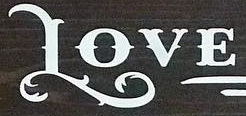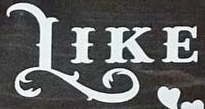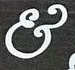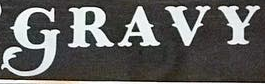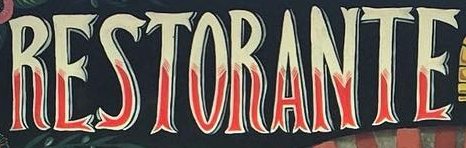Read the text content from these images in order, separated by a semicolon. LOVE; LIKE; &; GRAVY; RESTORANTE 